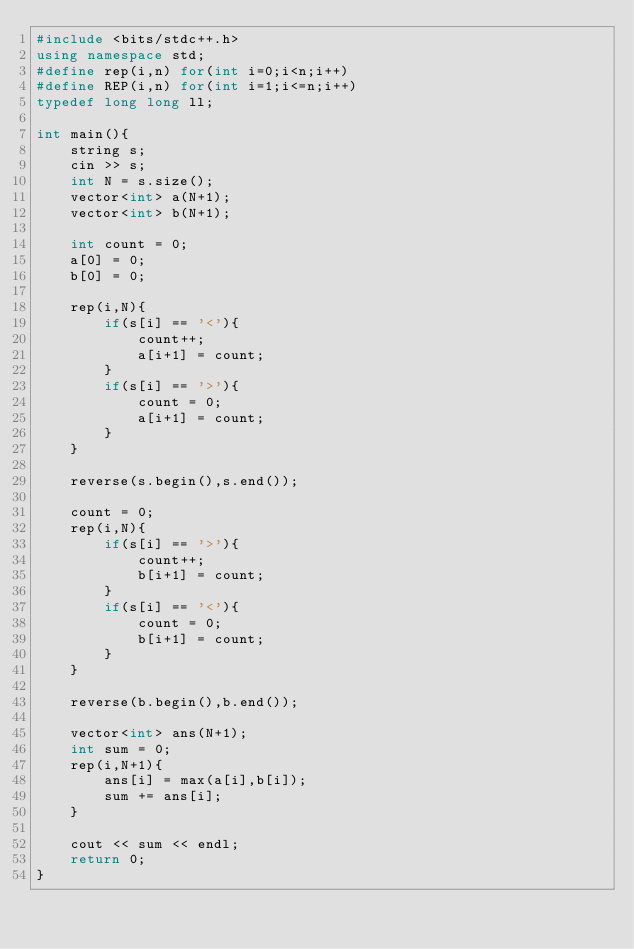<code> <loc_0><loc_0><loc_500><loc_500><_C++_>#include <bits/stdc++.h>
using namespace std;
#define rep(i,n) for(int i=0;i<n;i++)
#define REP(i,n) for(int i=1;i<=n;i++)
typedef long long ll;

int main(){
	string s;
	cin >> s;
	int N = s.size();
	vector<int> a(N+1);
	vector<int> b(N+1);
	
	int count = 0;
	a[0] = 0;
	b[0] = 0;
	
	rep(i,N){
		if(s[i] == '<'){
			count++;
			a[i+1] = count;
		}
		if(s[i] == '>'){
			count = 0;
			a[i+1] = count;
		}
	}
	
	reverse(s.begin(),s.end());
	
	count = 0;
	rep(i,N){
		if(s[i] == '>'){
			count++;
			b[i+1] = count;
		}
		if(s[i] == '<'){
			count = 0;
			b[i+1] = count;
		}
	}
	
	reverse(b.begin(),b.end());
	
	vector<int> ans(N+1);
	int sum = 0;
	rep(i,N+1){
		ans[i] = max(a[i],b[i]);
		sum += ans[i];
	}
	
	cout << sum << endl;
    return 0;
}</code> 